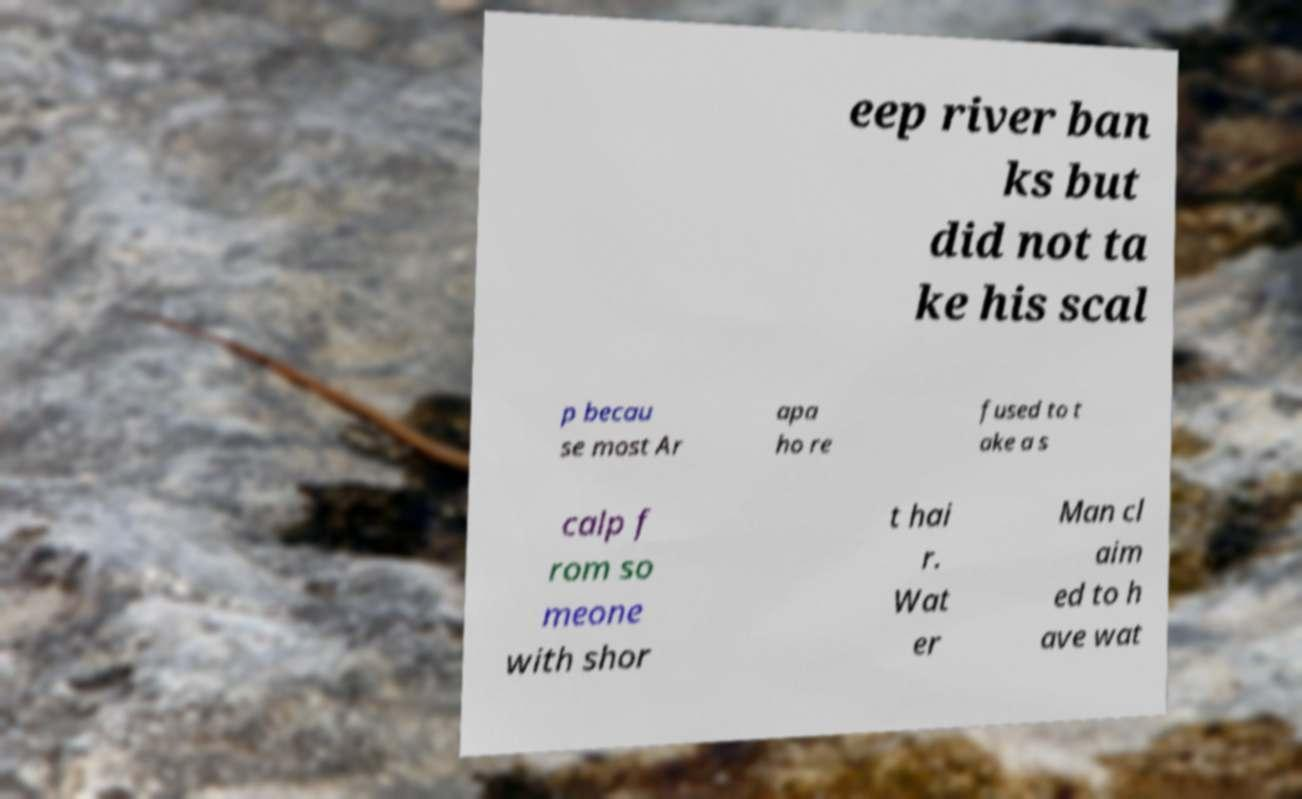I need the written content from this picture converted into text. Can you do that? eep river ban ks but did not ta ke his scal p becau se most Ar apa ho re fused to t ake a s calp f rom so meone with shor t hai r. Wat er Man cl aim ed to h ave wat 